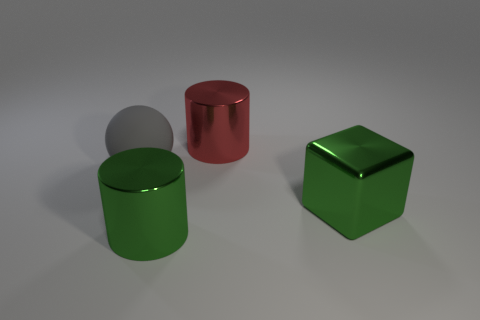Is there anything else that has the same material as the gray ball?
Give a very brief answer. No. There is a cylinder that is the same color as the big metallic block; what is its size?
Your answer should be very brief. Large. What number of large objects are either gray things or cylinders?
Provide a succinct answer. 3. The cube that is the same size as the sphere is what color?
Your answer should be compact. Green. How many other things are there of the same shape as the gray thing?
Ensure brevity in your answer.  0. Are there any green things made of the same material as the red thing?
Your answer should be compact. Yes. Are the large cylinder behind the large ball and the cylinder in front of the large matte ball made of the same material?
Provide a succinct answer. Yes. What number of things are there?
Offer a very short reply. 4. There is a metallic thing behind the gray matte sphere; what is its shape?
Offer a very short reply. Cylinder. How many other things are the same size as the rubber object?
Keep it short and to the point. 3. 